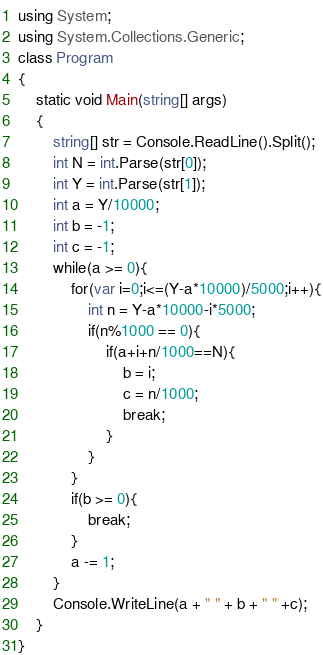<code> <loc_0><loc_0><loc_500><loc_500><_C#_>using System;
using System.Collections.Generic;
class Program
{
	static void Main(string[] args)
	{
		string[] str = Console.ReadLine().Split();
		int N = int.Parse(str[0]);
		int Y = int.Parse(str[1]);
		int a = Y/10000;
		int b = -1;
		int c = -1;
		while(a >= 0){
			for(var i=0;i<=(Y-a*10000)/5000;i++){
				int n = Y-a*10000-i*5000;
				if(n%1000 == 0){
					if(a+i+n/1000==N){
						b = i;
						c = n/1000;
						break;
					}
				}
			}
			if(b >= 0){
				break;
			}
			a -= 1;
		}
		Console.WriteLine(a + " " + b + " " +c);
	}
}</code> 